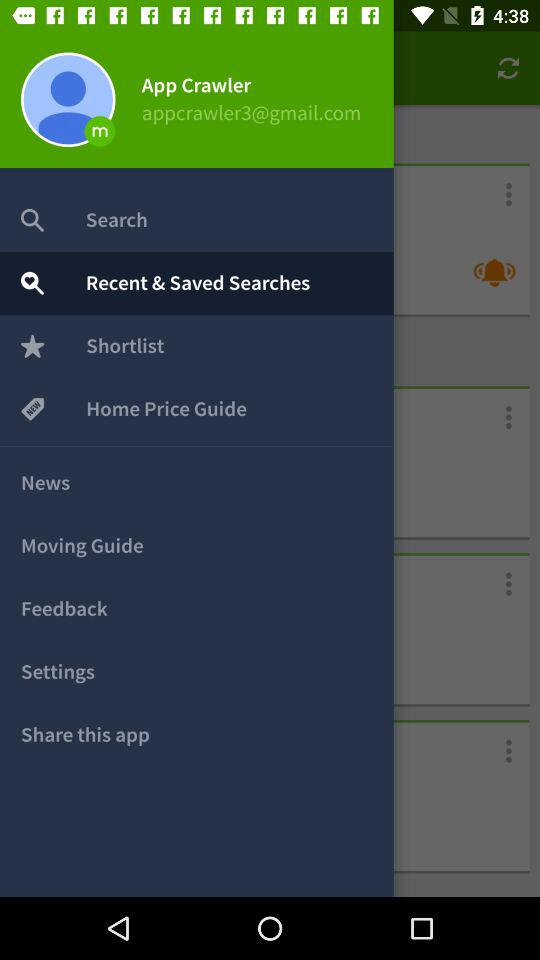What's the email address? The email address is appcrawler3@gmail.com. 